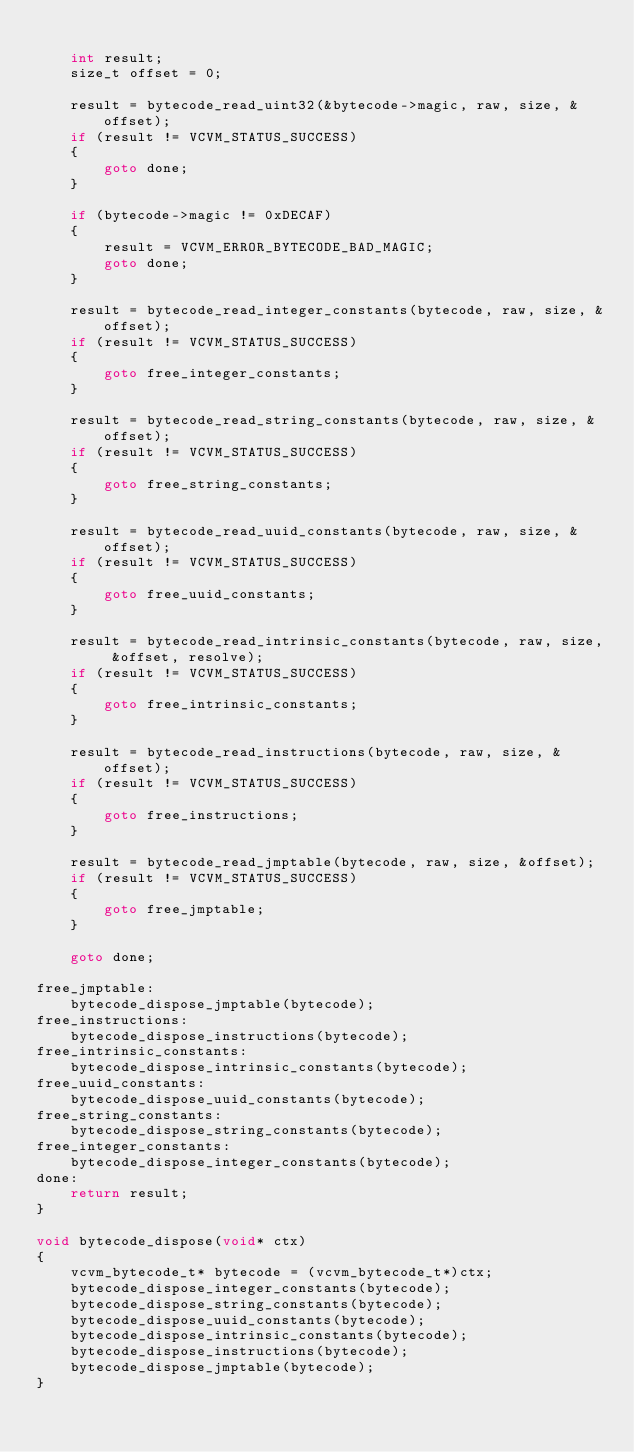Convert code to text. <code><loc_0><loc_0><loc_500><loc_500><_C_>
    int result;
    size_t offset = 0;

    result = bytecode_read_uint32(&bytecode->magic, raw, size, &offset);
    if (result != VCVM_STATUS_SUCCESS)
    {
        goto done;
    }

    if (bytecode->magic != 0xDECAF)
    {
        result = VCVM_ERROR_BYTECODE_BAD_MAGIC;
        goto done;
    }

    result = bytecode_read_integer_constants(bytecode, raw, size, &offset);
    if (result != VCVM_STATUS_SUCCESS)
    {
        goto free_integer_constants;
    }

    result = bytecode_read_string_constants(bytecode, raw, size, &offset);
    if (result != VCVM_STATUS_SUCCESS)
    {
        goto free_string_constants;
    }

    result = bytecode_read_uuid_constants(bytecode, raw, size, &offset);
    if (result != VCVM_STATUS_SUCCESS)
    {
        goto free_uuid_constants;
    }

    result = bytecode_read_intrinsic_constants(bytecode, raw, size, &offset, resolve);
    if (result != VCVM_STATUS_SUCCESS)
    {
        goto free_intrinsic_constants;
    }

    result = bytecode_read_instructions(bytecode, raw, size, &offset);
    if (result != VCVM_STATUS_SUCCESS)
    {
        goto free_instructions;
    }

    result = bytecode_read_jmptable(bytecode, raw, size, &offset);
    if (result != VCVM_STATUS_SUCCESS)
    {
        goto free_jmptable;
    }

    goto done;

free_jmptable:
    bytecode_dispose_jmptable(bytecode);
free_instructions:
    bytecode_dispose_instructions(bytecode);
free_intrinsic_constants:
    bytecode_dispose_intrinsic_constants(bytecode);
free_uuid_constants:
    bytecode_dispose_uuid_constants(bytecode);
free_string_constants:
    bytecode_dispose_string_constants(bytecode);
free_integer_constants:
    bytecode_dispose_integer_constants(bytecode);
done:
    return result;
}

void bytecode_dispose(void* ctx)
{
    vcvm_bytecode_t* bytecode = (vcvm_bytecode_t*)ctx;
    bytecode_dispose_integer_constants(bytecode);
    bytecode_dispose_string_constants(bytecode);
    bytecode_dispose_uuid_constants(bytecode);
    bytecode_dispose_intrinsic_constants(bytecode);
    bytecode_dispose_instructions(bytecode);
    bytecode_dispose_jmptable(bytecode);
}
</code> 